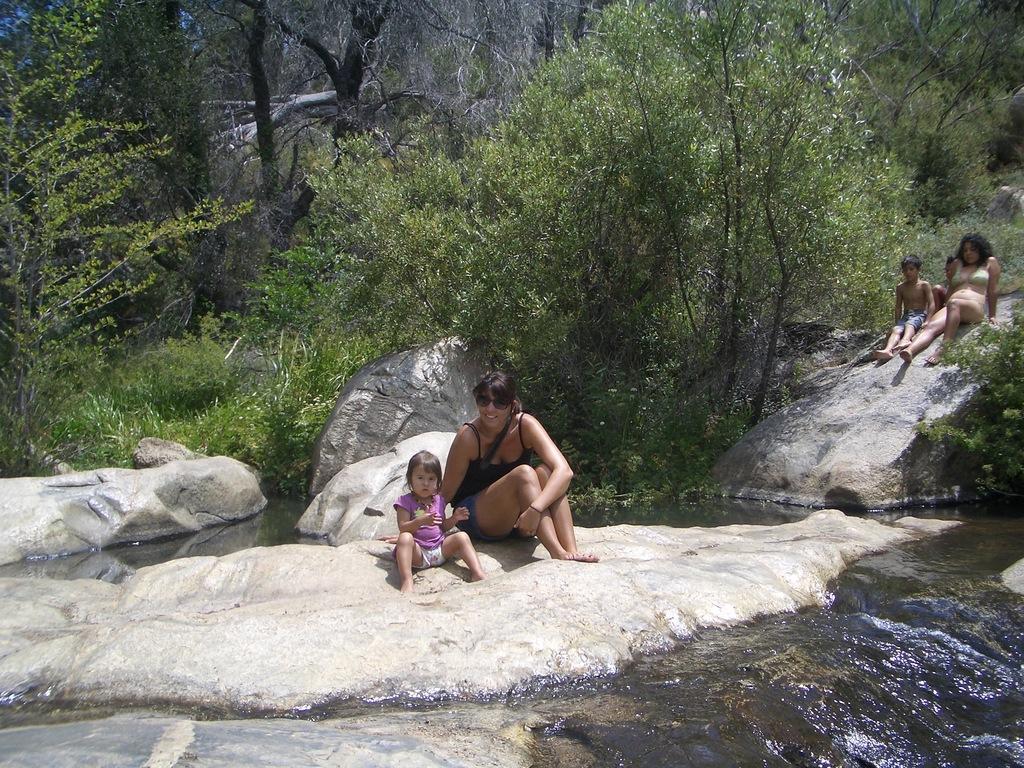Could you give a brief overview of what you see in this image? In this image I can see few people sitting on the rocks. I can see one person wearing the goggles. To the side of these people I can see the water and many trees. 